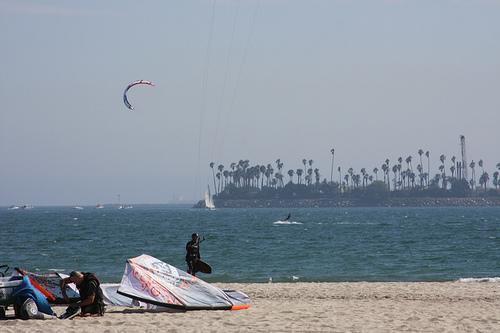How many people are on the beach?
Give a very brief answer. 2. How many types of water sports are depicted?
Give a very brief answer. 2. How many of the train cars are yellow and red?
Give a very brief answer. 0. 